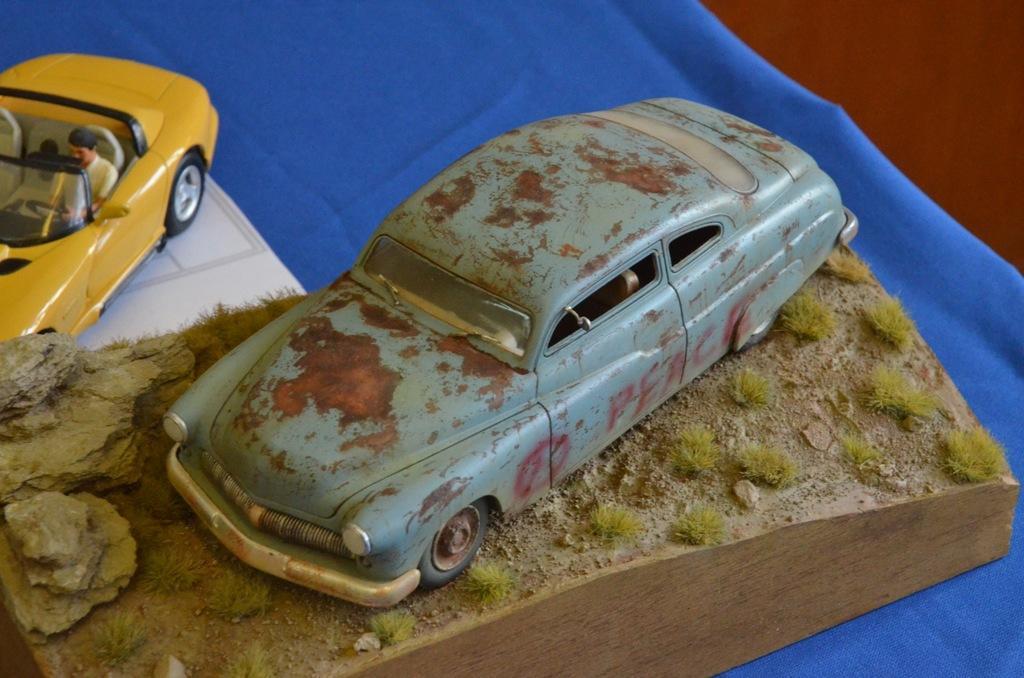In one or two sentences, can you explain what this image depicts? In the picture there are two car toys kept on a blue cloth. 